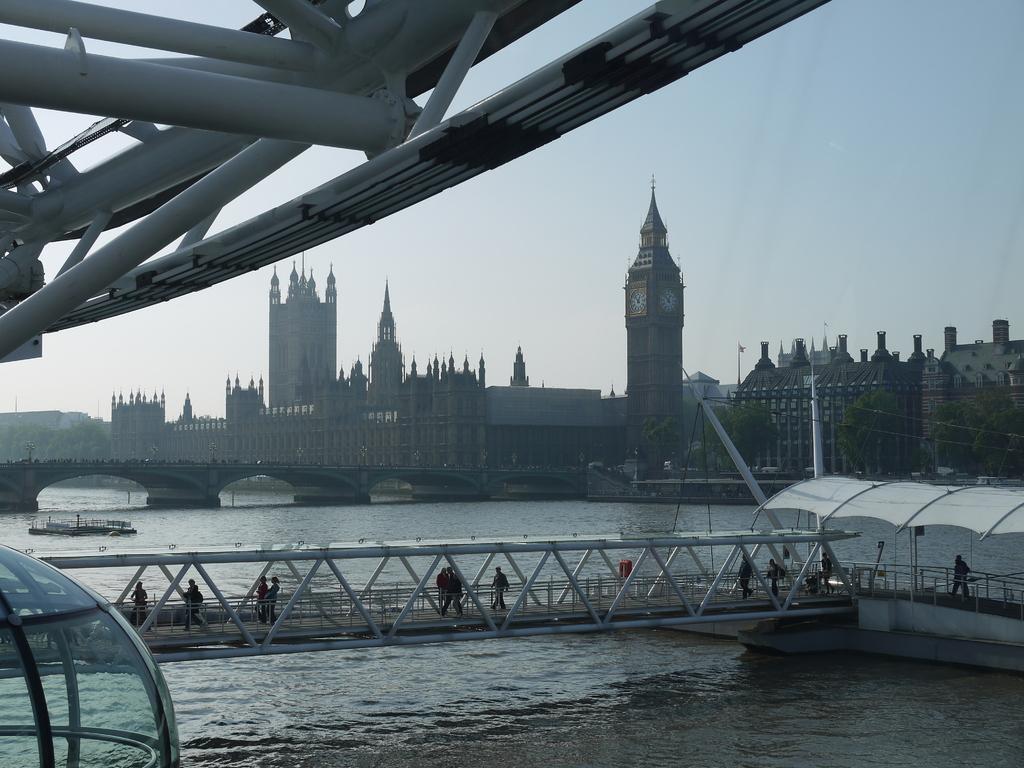Can you describe this image briefly? In the center of the image we can see buildings, brides, tent, poles, flag, some persons, water are there. At the top of the image we can see sky, rods are there. At the bottom left corner a glass is there. 